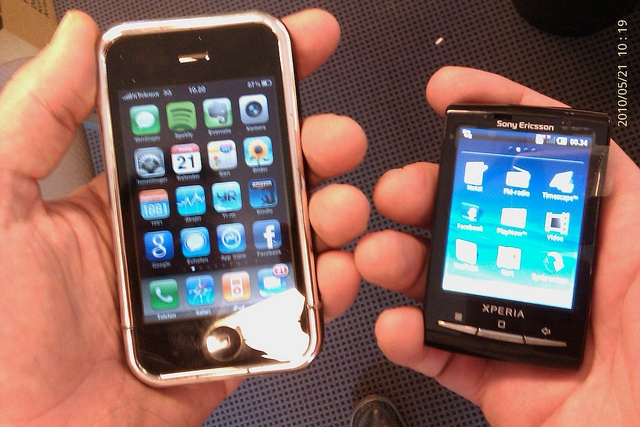Describe the objects in this image and their specific colors. I can see cell phone in brown, black, white, gray, and maroon tones, people in brown and salmon tones, cell phone in brown, black, white, cyan, and lightblue tones, people in brown and salmon tones, and people in brown, tan, salmon, and maroon tones in this image. 